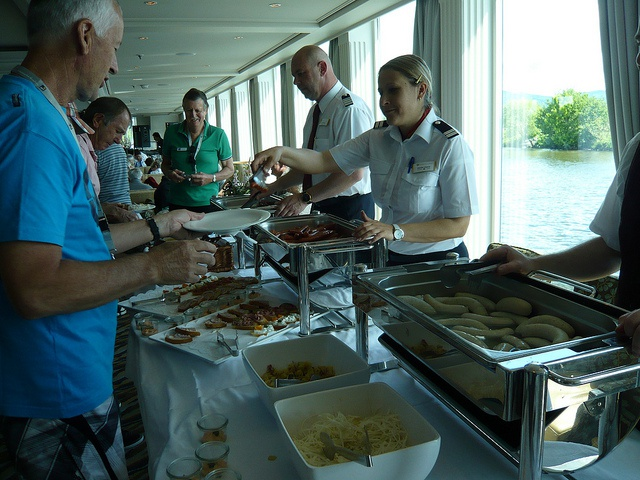Describe the objects in this image and their specific colors. I can see people in black, teal, navy, and gray tones, people in black, gray, and purple tones, bowl in black, darkgreen, and teal tones, people in black, gray, purple, and lightblue tones, and people in black, gray, and purple tones in this image. 